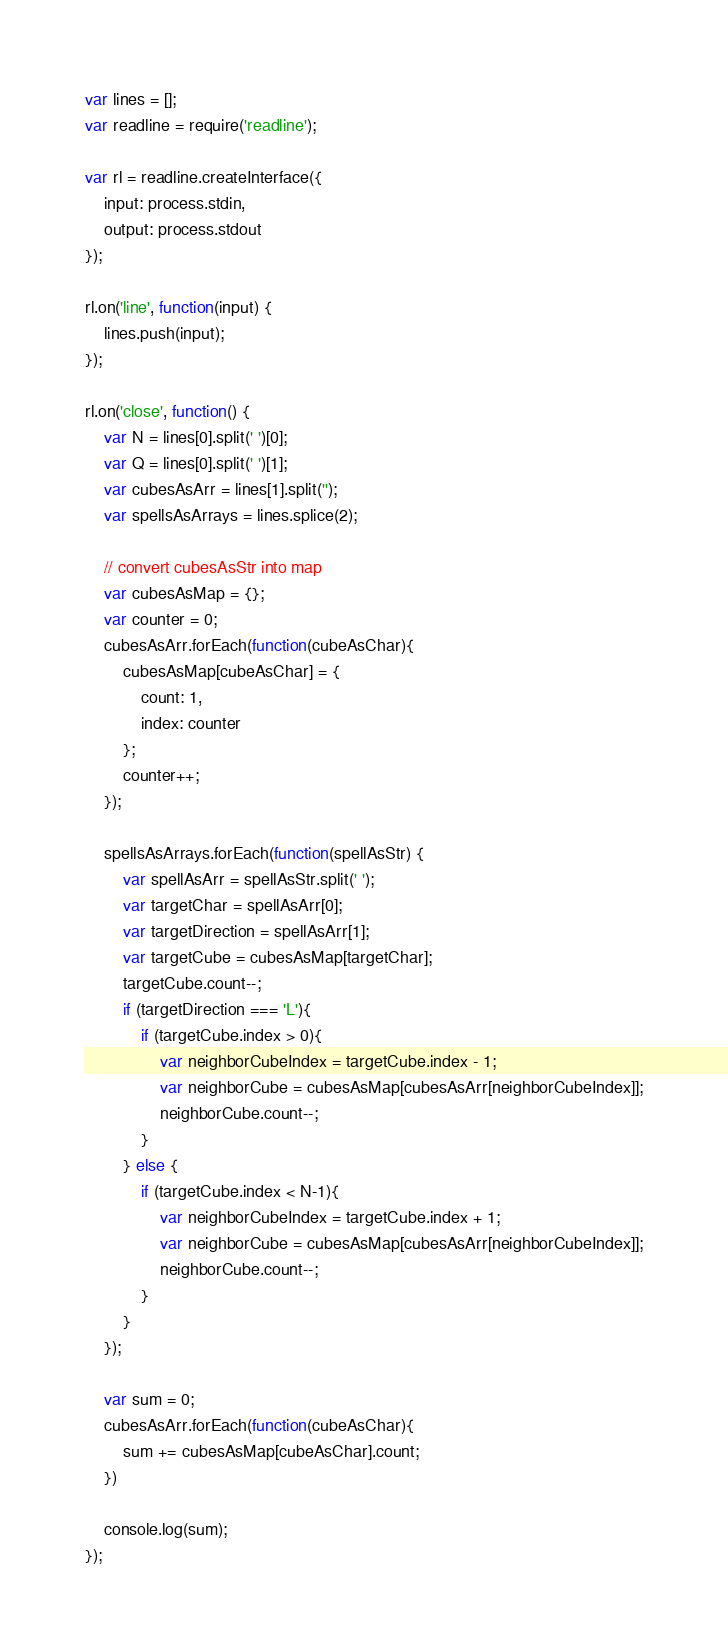Convert code to text. <code><loc_0><loc_0><loc_500><loc_500><_JavaScript_>var lines = [];
var readline = require('readline');

var rl = readline.createInterface({
    input: process.stdin,
    output: process.stdout
});

rl.on('line', function(input) {
    lines.push(input);
});

rl.on('close', function() {
    var N = lines[0].split(' ')[0];
    var Q = lines[0].split(' ')[1];
    var cubesAsArr = lines[1].split('');
    var spellsAsArrays = lines.splice(2);

    // convert cubesAsStr into map 
    var cubesAsMap = {};
    var counter = 0;
    cubesAsArr.forEach(function(cubeAsChar){
        cubesAsMap[cubeAsChar] = {
            count: 1,
            index: counter
        };
        counter++;
    });

    spellsAsArrays.forEach(function(spellAsStr) {
        var spellAsArr = spellAsStr.split(' ');
        var targetChar = spellAsArr[0];
        var targetDirection = spellAsArr[1];
        var targetCube = cubesAsMap[targetChar];
        targetCube.count--;
        if (targetDirection === 'L'){
            if (targetCube.index > 0){
                var neighborCubeIndex = targetCube.index - 1;
                var neighborCube = cubesAsMap[cubesAsArr[neighborCubeIndex]];
                neighborCube.count--;
            }
        } else {
            if (targetCube.index < N-1){
                var neighborCubeIndex = targetCube.index + 1;
                var neighborCube = cubesAsMap[cubesAsArr[neighborCubeIndex]];
                neighborCube.count--;
            }        
        }
    });

    var sum = 0;
    cubesAsArr.forEach(function(cubeAsChar){
        sum += cubesAsMap[cubeAsChar].count;
    })

    console.log(sum);
});
</code> 